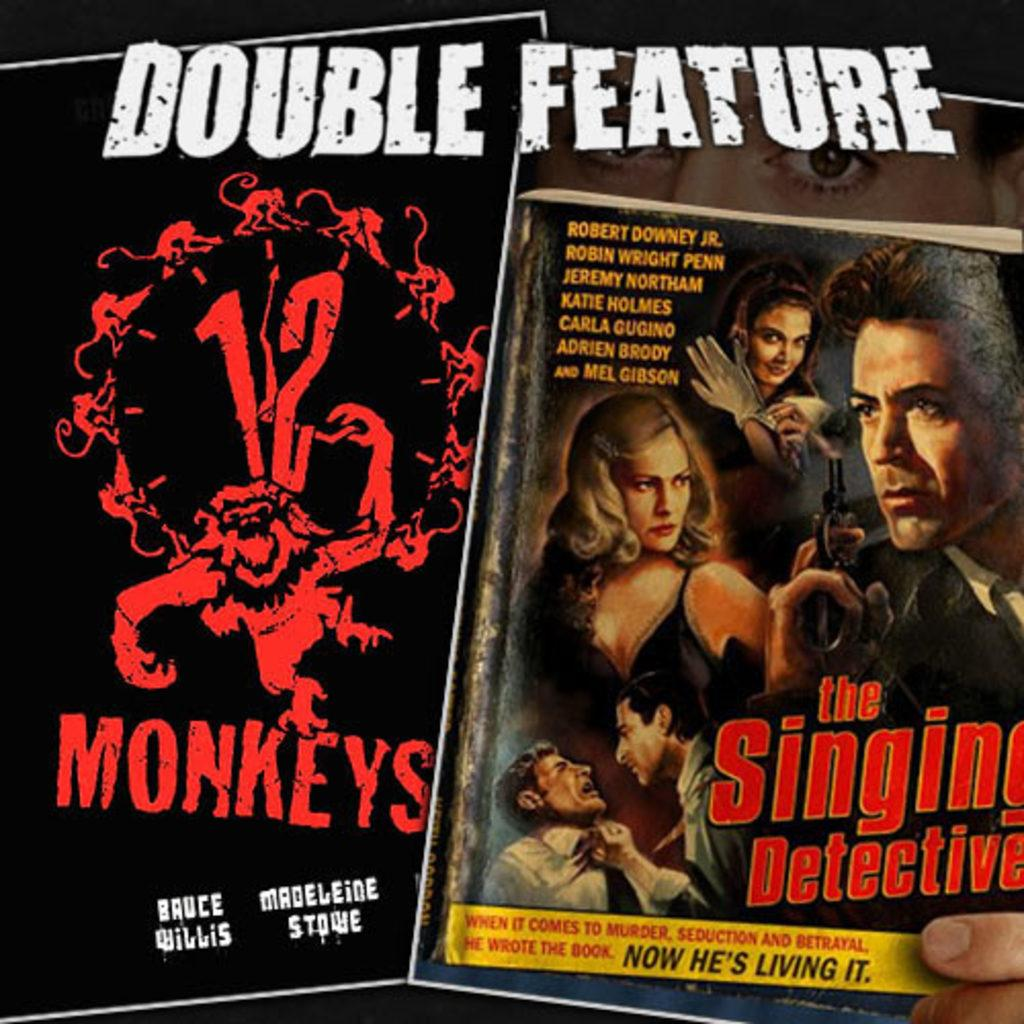<image>
Describe the image concisely. Two dvd covers are shown; one is 12 monkeys and the other is the singing detective. 